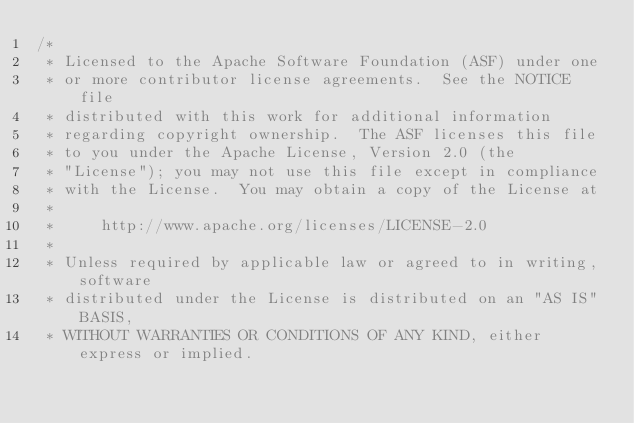<code> <loc_0><loc_0><loc_500><loc_500><_Java_>/*
 * Licensed to the Apache Software Foundation (ASF) under one
 * or more contributor license agreements.  See the NOTICE file
 * distributed with this work for additional information
 * regarding copyright ownership.  The ASF licenses this file
 * to you under the Apache License, Version 2.0 (the
 * "License"); you may not use this file except in compliance
 * with the License.  You may obtain a copy of the License at
 *
 *     http://www.apache.org/licenses/LICENSE-2.0
 *
 * Unless required by applicable law or agreed to in writing, software
 * distributed under the License is distributed on an "AS IS" BASIS,
 * WITHOUT WARRANTIES OR CONDITIONS OF ANY KIND, either express or implied.</code> 